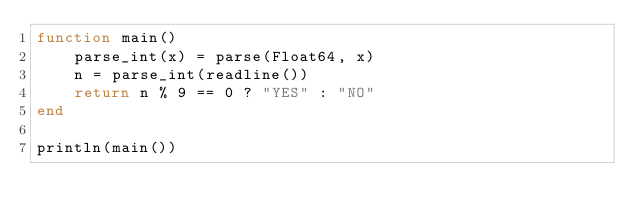Convert code to text. <code><loc_0><loc_0><loc_500><loc_500><_Julia_>function main()
    parse_int(x) = parse(Float64, x)
    n = parse_int(readline())
    return n % 9 == 0 ? "YES" : "NO"
end

println(main())</code> 